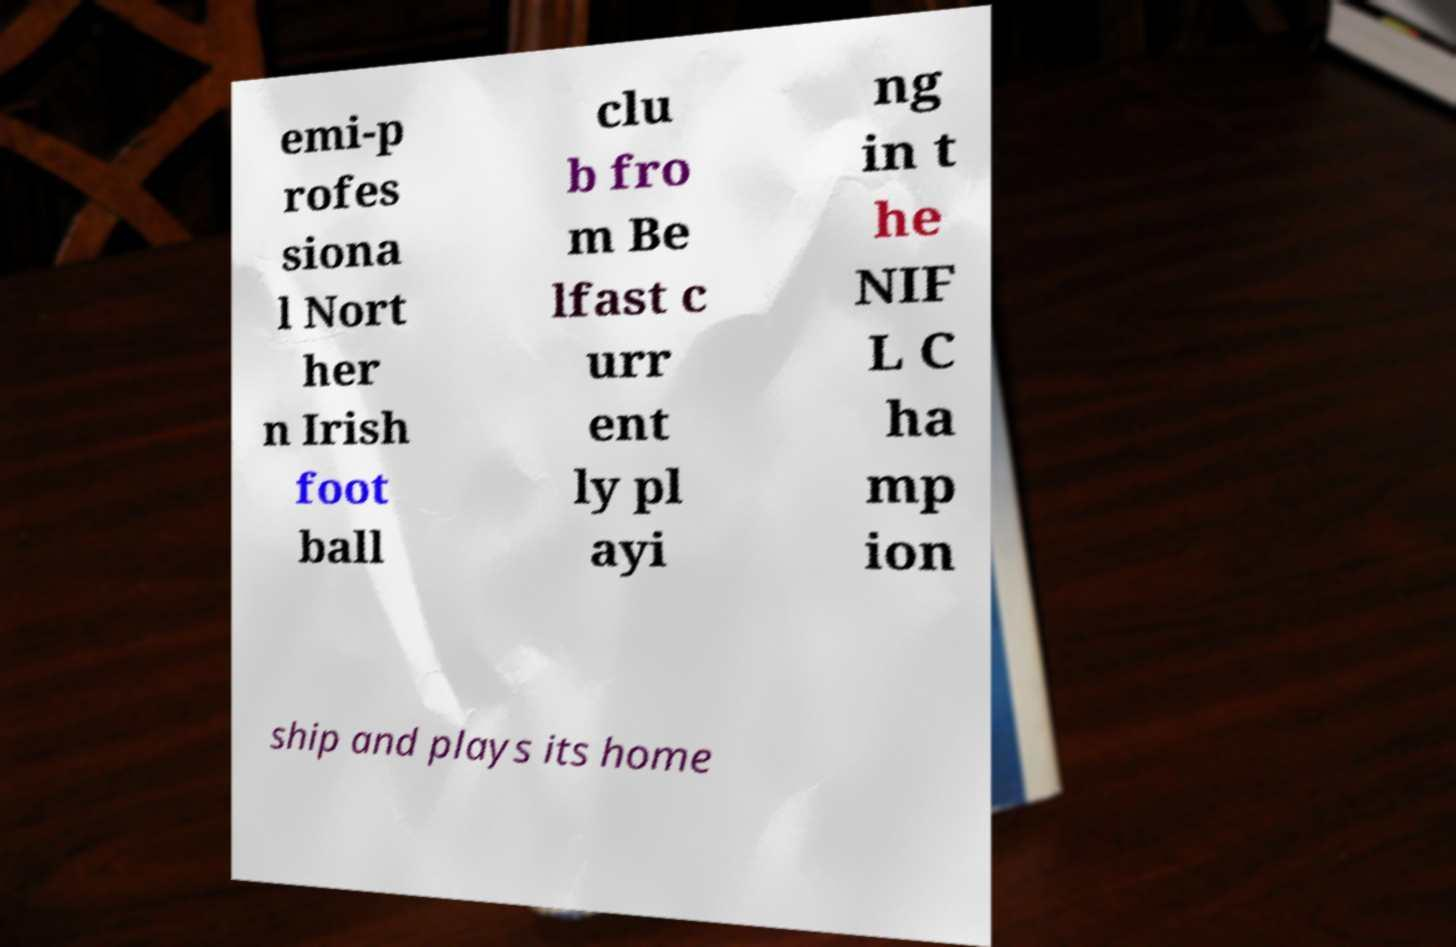Could you extract and type out the text from this image? emi-p rofes siona l Nort her n Irish foot ball clu b fro m Be lfast c urr ent ly pl ayi ng in t he NIF L C ha mp ion ship and plays its home 